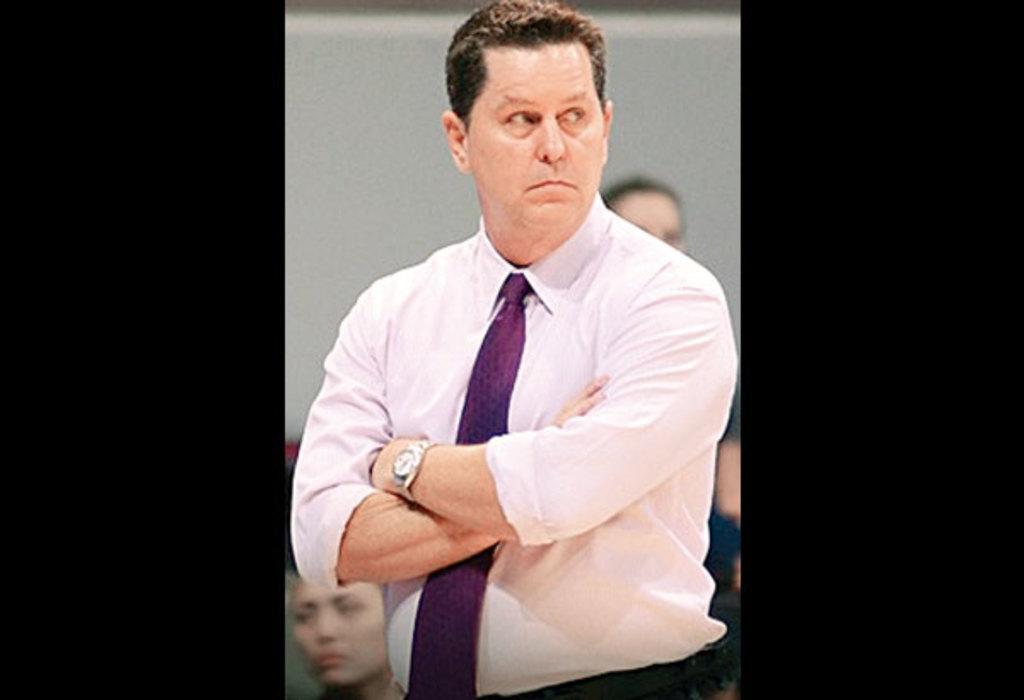Please provide a concise description of this image. This image consists of a man wearing white shirt and a purple color tie. In the background, there are many people. 